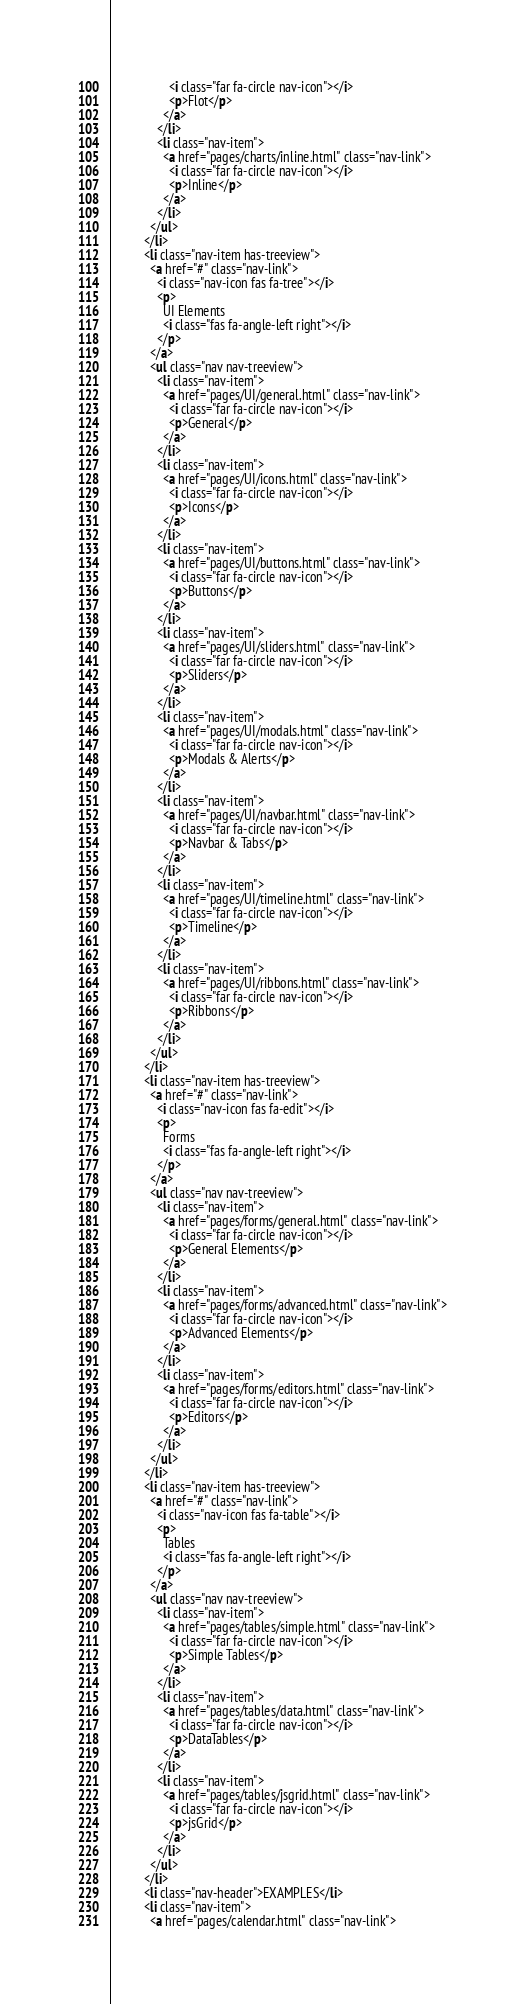<code> <loc_0><loc_0><loc_500><loc_500><_HTML_>                  <i class="far fa-circle nav-icon"></i>
                  <p>Flot</p>
                </a>
              </li>
              <li class="nav-item">
                <a href="pages/charts/inline.html" class="nav-link">
                  <i class="far fa-circle nav-icon"></i>
                  <p>Inline</p>
                </a>
              </li>
            </ul>
          </li>
          <li class="nav-item has-treeview">
            <a href="#" class="nav-link">
              <i class="nav-icon fas fa-tree"></i>
              <p>
                UI Elements
                <i class="fas fa-angle-left right"></i>
              </p>
            </a>
            <ul class="nav nav-treeview">
              <li class="nav-item">
                <a href="pages/UI/general.html" class="nav-link">
                  <i class="far fa-circle nav-icon"></i>
                  <p>General</p>
                </a>
              </li>
              <li class="nav-item">
                <a href="pages/UI/icons.html" class="nav-link">
                  <i class="far fa-circle nav-icon"></i>
                  <p>Icons</p>
                </a>
              </li>
              <li class="nav-item">
                <a href="pages/UI/buttons.html" class="nav-link">
                  <i class="far fa-circle nav-icon"></i>
                  <p>Buttons</p>
                </a>
              </li>
              <li class="nav-item">
                <a href="pages/UI/sliders.html" class="nav-link">
                  <i class="far fa-circle nav-icon"></i>
                  <p>Sliders</p>
                </a>
              </li>
              <li class="nav-item">
                <a href="pages/UI/modals.html" class="nav-link">
                  <i class="far fa-circle nav-icon"></i>
                  <p>Modals & Alerts</p>
                </a>
              </li>
              <li class="nav-item">
                <a href="pages/UI/navbar.html" class="nav-link">
                  <i class="far fa-circle nav-icon"></i>
                  <p>Navbar & Tabs</p>
                </a>
              </li>
              <li class="nav-item">
                <a href="pages/UI/timeline.html" class="nav-link">
                  <i class="far fa-circle nav-icon"></i>
                  <p>Timeline</p>
                </a>
              </li>
              <li class="nav-item">
                <a href="pages/UI/ribbons.html" class="nav-link">
                  <i class="far fa-circle nav-icon"></i>
                  <p>Ribbons</p>
                </a>
              </li>
            </ul>
          </li>
          <li class="nav-item has-treeview">
            <a href="#" class="nav-link">
              <i class="nav-icon fas fa-edit"></i>
              <p>
                Forms
                <i class="fas fa-angle-left right"></i>
              </p>
            </a>
            <ul class="nav nav-treeview">
              <li class="nav-item">
                <a href="pages/forms/general.html" class="nav-link">
                  <i class="far fa-circle nav-icon"></i>
                  <p>General Elements</p>
                </a>
              </li>
              <li class="nav-item">
                <a href="pages/forms/advanced.html" class="nav-link">
                  <i class="far fa-circle nav-icon"></i>
                  <p>Advanced Elements</p>
                </a>
              </li>
              <li class="nav-item">
                <a href="pages/forms/editors.html" class="nav-link">
                  <i class="far fa-circle nav-icon"></i>
                  <p>Editors</p>
                </a>
              </li>
            </ul>
          </li>
          <li class="nav-item has-treeview">
            <a href="#" class="nav-link">
              <i class="nav-icon fas fa-table"></i>
              <p>
                Tables
                <i class="fas fa-angle-left right"></i>
              </p>
            </a>
            <ul class="nav nav-treeview">
              <li class="nav-item">
                <a href="pages/tables/simple.html" class="nav-link">
                  <i class="far fa-circle nav-icon"></i>
                  <p>Simple Tables</p>
                </a>
              </li>
              <li class="nav-item">
                <a href="pages/tables/data.html" class="nav-link">
                  <i class="far fa-circle nav-icon"></i>
                  <p>DataTables</p>
                </a>
              </li>
              <li class="nav-item">
                <a href="pages/tables/jsgrid.html" class="nav-link">
                  <i class="far fa-circle nav-icon"></i>
                  <p>jsGrid</p>
                </a>
              </li>
            </ul>
          </li>
          <li class="nav-header">EXAMPLES</li>
          <li class="nav-item">
            <a href="pages/calendar.html" class="nav-link"></code> 